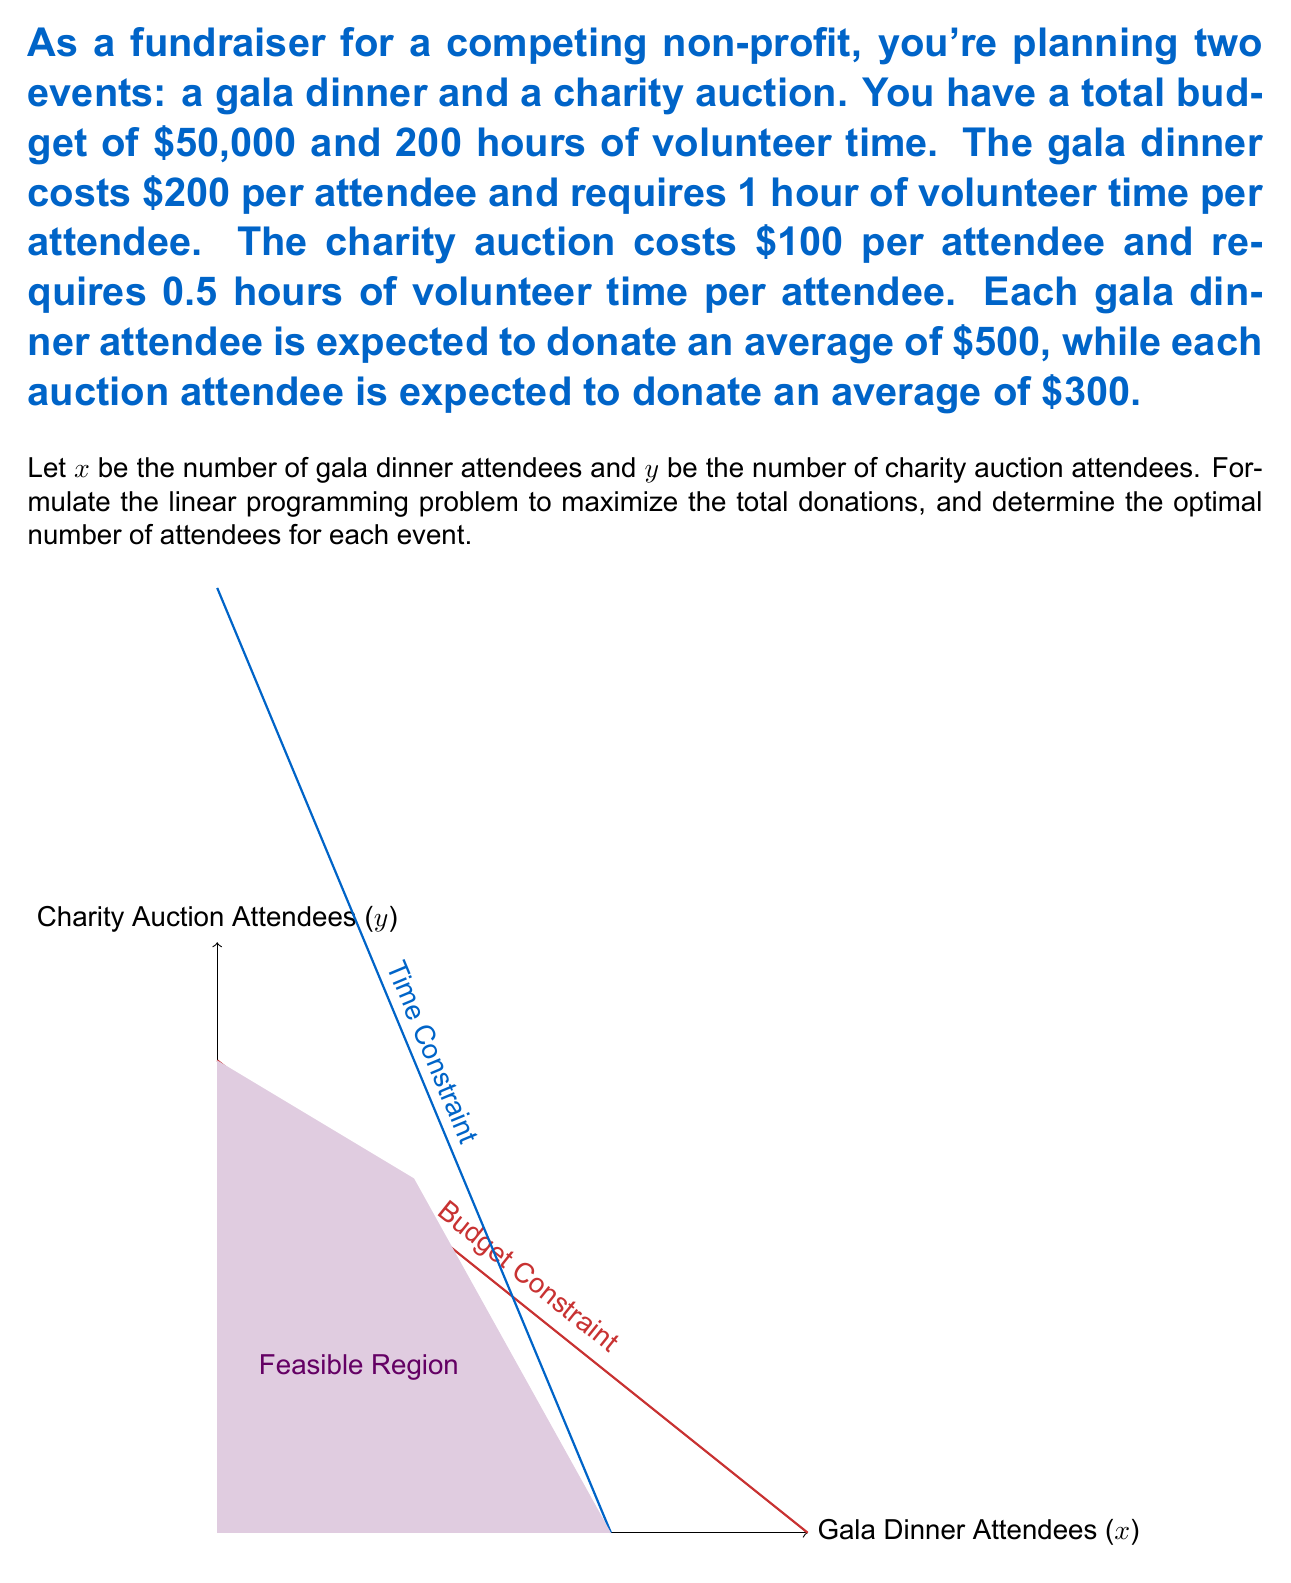Could you help me with this problem? Let's approach this problem step-by-step:

1) First, we need to formulate the objective function. We want to maximize the total donations:
   Maximize $Z = 500x + 300y$

2) Now, let's identify the constraints:

   a) Budget constraint: $200x + 100y \leq 50000$
   b) Time constraint: $1x + 0.5y \leq 200$
   c) Non-negativity: $x \geq 0$, $y \geq 0$

3) Simplify the constraints:
   a) $2x + y \leq 500$
   b) $2x + y \leq 400$

4) The feasible region is bounded by these constraints, as shown in the graph.

5) To find the optimal solution, we need to check the corner points of the feasible region:
   - (0, 0): Z = 0
   - (0, 400): Z = 120,000
   - (166.67, 66.67): Z = 103,333.5
   - (125, 150): Z = 107,500

6) The optimal solution is at the point (0, 400), which gives the maximum Z value of 120,000.

7) However, we need integer solutions. The closest integer point is (0, 400).

Therefore, the optimal solution is to have 0 gala dinner attendees and 400 charity auction attendees.
Answer: 0 gala dinner attendees, 400 charity auction attendees 